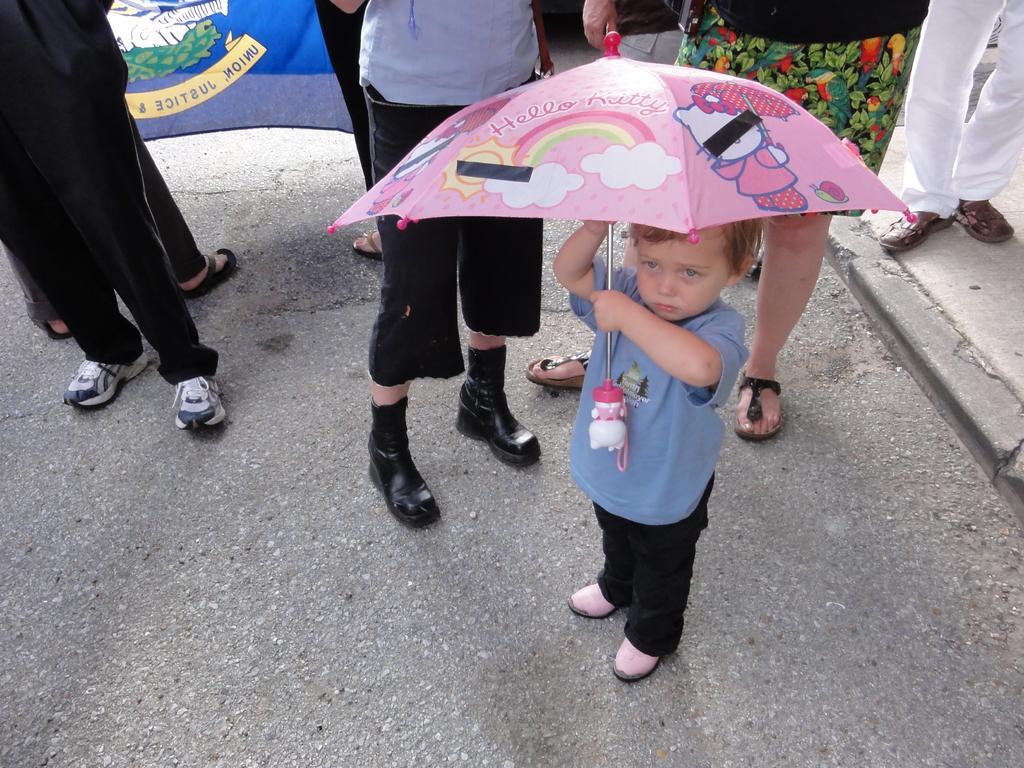Describe this image in one or two sentences. In this picture there is a boy standing and holding the pink color umbrella. At the back there are group of people standing. At the bottom there is a road. 